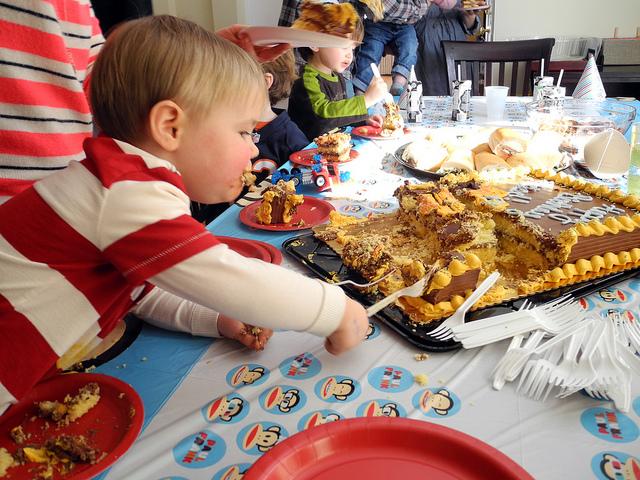What character is pictured on the tablecloth?
Answer briefly. Monkey. Is this a birthday party?
Quick response, please. Yes. What character is shown on the tablecloth?
Write a very short answer. Monkey. What color is the tablecloth?
Answer briefly. Blue, white. Who is cutting the cake?
Write a very short answer. Baby. 